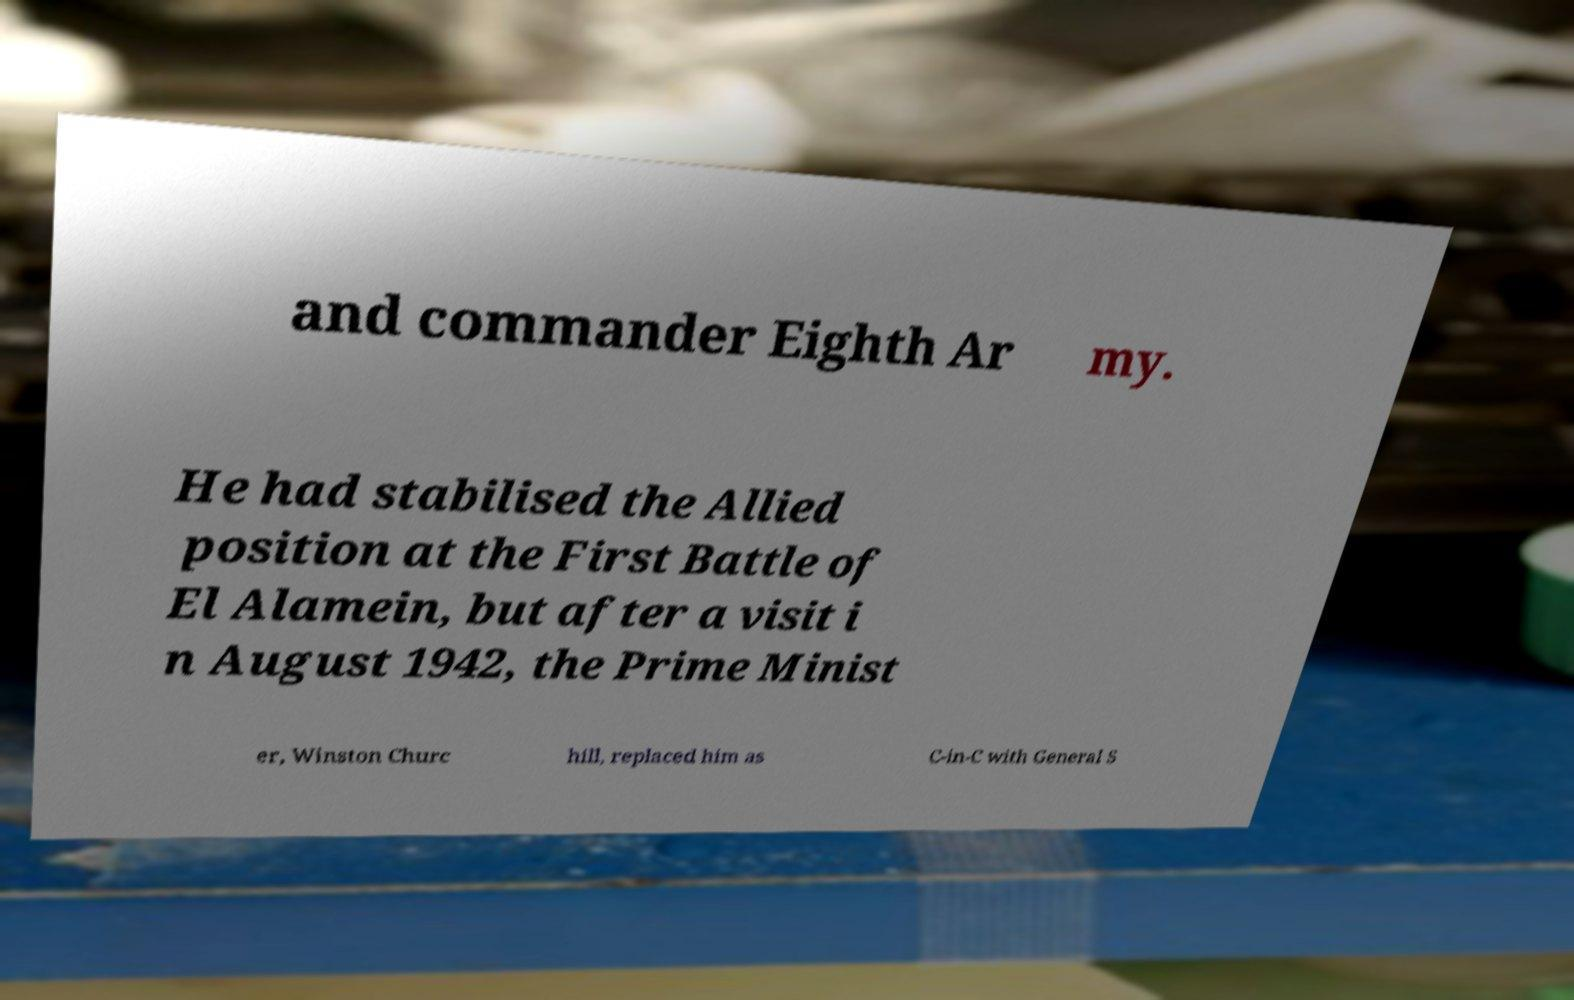I need the written content from this picture converted into text. Can you do that? and commander Eighth Ar my. He had stabilised the Allied position at the First Battle of El Alamein, but after a visit i n August 1942, the Prime Minist er, Winston Churc hill, replaced him as C-in-C with General S 